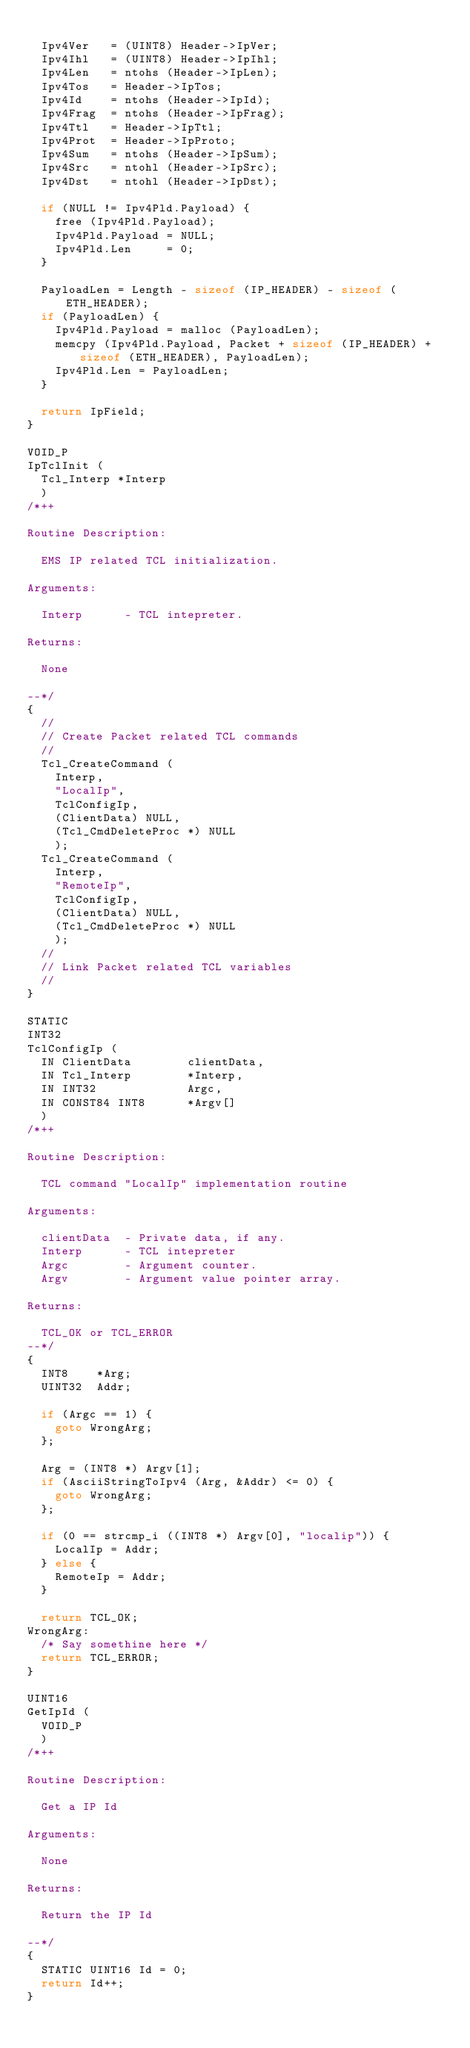Convert code to text. <code><loc_0><loc_0><loc_500><loc_500><_C_>
  Ipv4Ver   = (UINT8) Header->IpVer;
  Ipv4Ihl   = (UINT8) Header->IpIhl;
  Ipv4Len   = ntohs (Header->IpLen);
  Ipv4Tos   = Header->IpTos;
  Ipv4Id    = ntohs (Header->IpId);
  Ipv4Frag  = ntohs (Header->IpFrag);
  Ipv4Ttl   = Header->IpTtl;
  Ipv4Prot  = Header->IpProto;
  Ipv4Sum   = ntohs (Header->IpSum);
  Ipv4Src   = ntohl (Header->IpSrc);
  Ipv4Dst   = ntohl (Header->IpDst);

  if (NULL != Ipv4Pld.Payload) {
    free (Ipv4Pld.Payload);
    Ipv4Pld.Payload = NULL;
    Ipv4Pld.Len     = 0;
  }

  PayloadLen = Length - sizeof (IP_HEADER) - sizeof (ETH_HEADER);
  if (PayloadLen) {
    Ipv4Pld.Payload = malloc (PayloadLen);
    memcpy (Ipv4Pld.Payload, Packet + sizeof (IP_HEADER) + sizeof (ETH_HEADER), PayloadLen);
    Ipv4Pld.Len = PayloadLen;
  }

  return IpField;
}

VOID_P
IpTclInit (
  Tcl_Interp *Interp
  )
/*++

Routine Description:

  EMS IP related TCL initialization.

Arguments:

  Interp      - TCL intepreter.

Returns:

  None

--*/
{
  //
  // Create Packet related TCL commands
  //
  Tcl_CreateCommand (
    Interp,
    "LocalIp",
    TclConfigIp,
    (ClientData) NULL,
    (Tcl_CmdDeleteProc *) NULL
    );
  Tcl_CreateCommand (
    Interp,
    "RemoteIp",
    TclConfigIp,
    (ClientData) NULL,
    (Tcl_CmdDeleteProc *) NULL
    );
  //
  // Link Packet related TCL variables
  //
}

STATIC
INT32
TclConfigIp (
  IN ClientData        clientData,
  IN Tcl_Interp        *Interp,
  IN INT32             Argc,
  IN CONST84 INT8      *Argv[]
  )
/*++

Routine Description:

  TCL command "LocalIp" implementation routine  

Arguments:

  clientData  - Private data, if any.
  Interp      - TCL intepreter
  Argc        - Argument counter.
  Argv        - Argument value pointer array.

Returns:

  TCL_OK or TCL_ERROR
--*/
{
  INT8    *Arg;
  UINT32  Addr;

  if (Argc == 1) {
    goto WrongArg;
  };

  Arg = (INT8 *) Argv[1];
  if (AsciiStringToIpv4 (Arg, &Addr) <= 0) {
    goto WrongArg;
  };

  if (0 == strcmp_i ((INT8 *) Argv[0], "localip")) {
    LocalIp = Addr;
  } else {
    RemoteIp = Addr;
  }

  return TCL_OK;
WrongArg:
  /* Say somethine here */
  return TCL_ERROR;
}

UINT16
GetIpId (
  VOID_P
  )
/*++

Routine Description:

  Get a IP Id

Arguments:

  None

Returns:

  Return the IP Id

--*/
{
  STATIC UINT16 Id = 0;
  return Id++;
}
</code> 